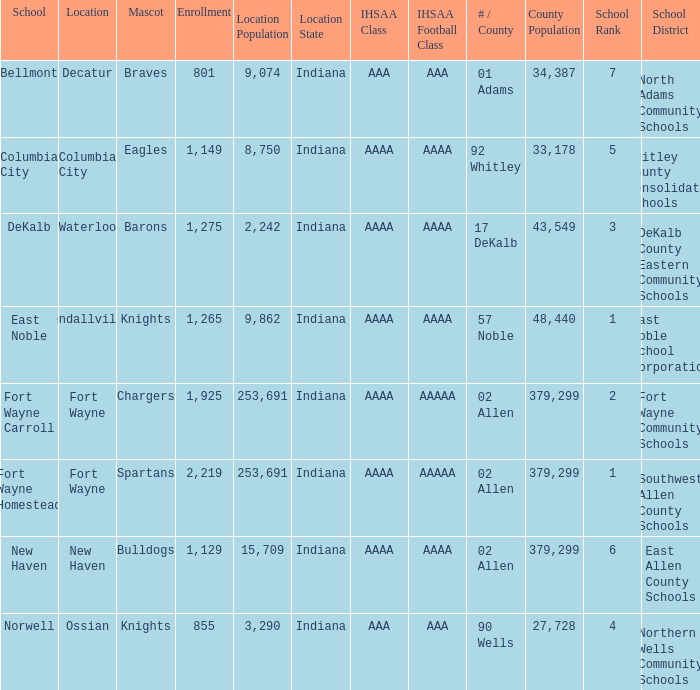What school has a mascot of the spartans with an AAAA IHSAA class and more than 1,275 enrolled? Fort Wayne Homestead. 